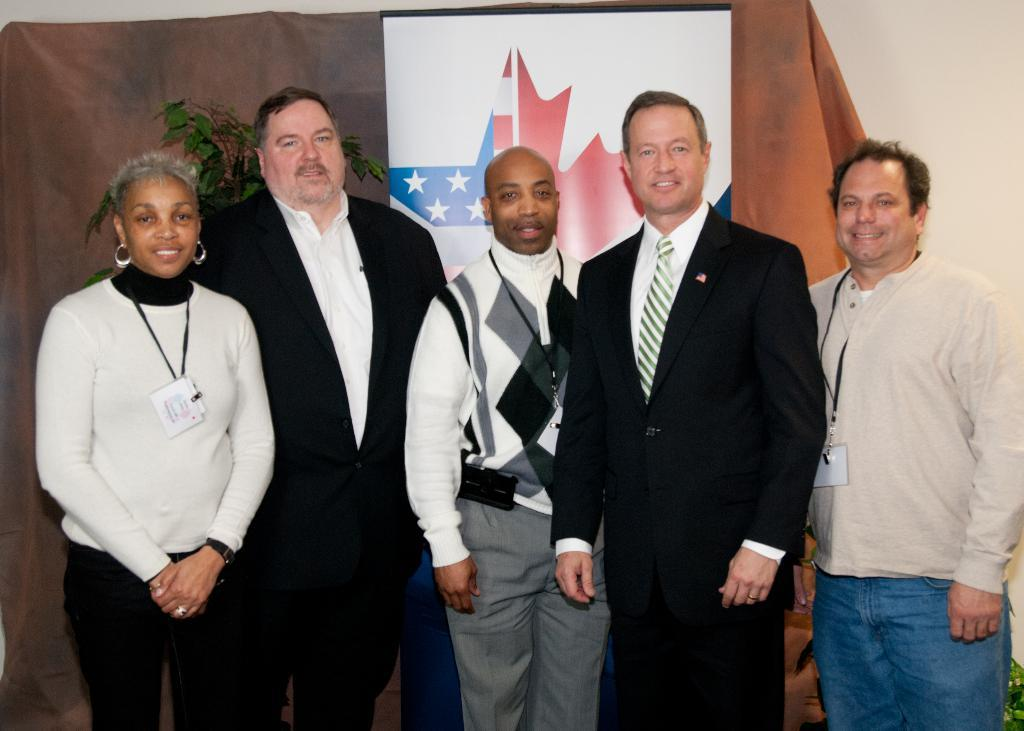What are the persons in the image wearing? The persons in the image are wearing different color dresses. What is the facial expression of the persons in the image? The persons are smiling. What position are the persons in the image? The persons are standing. What can be seen in the background of the image? There is a banner, a curtain, a plant, and a white wall in the background of the image. What type of protest is taking place in the image? There is no protest present in the image; it features persons standing and smiling in different color dresses. What is the purpose of the basin in the image? There is no basin present in the image. 